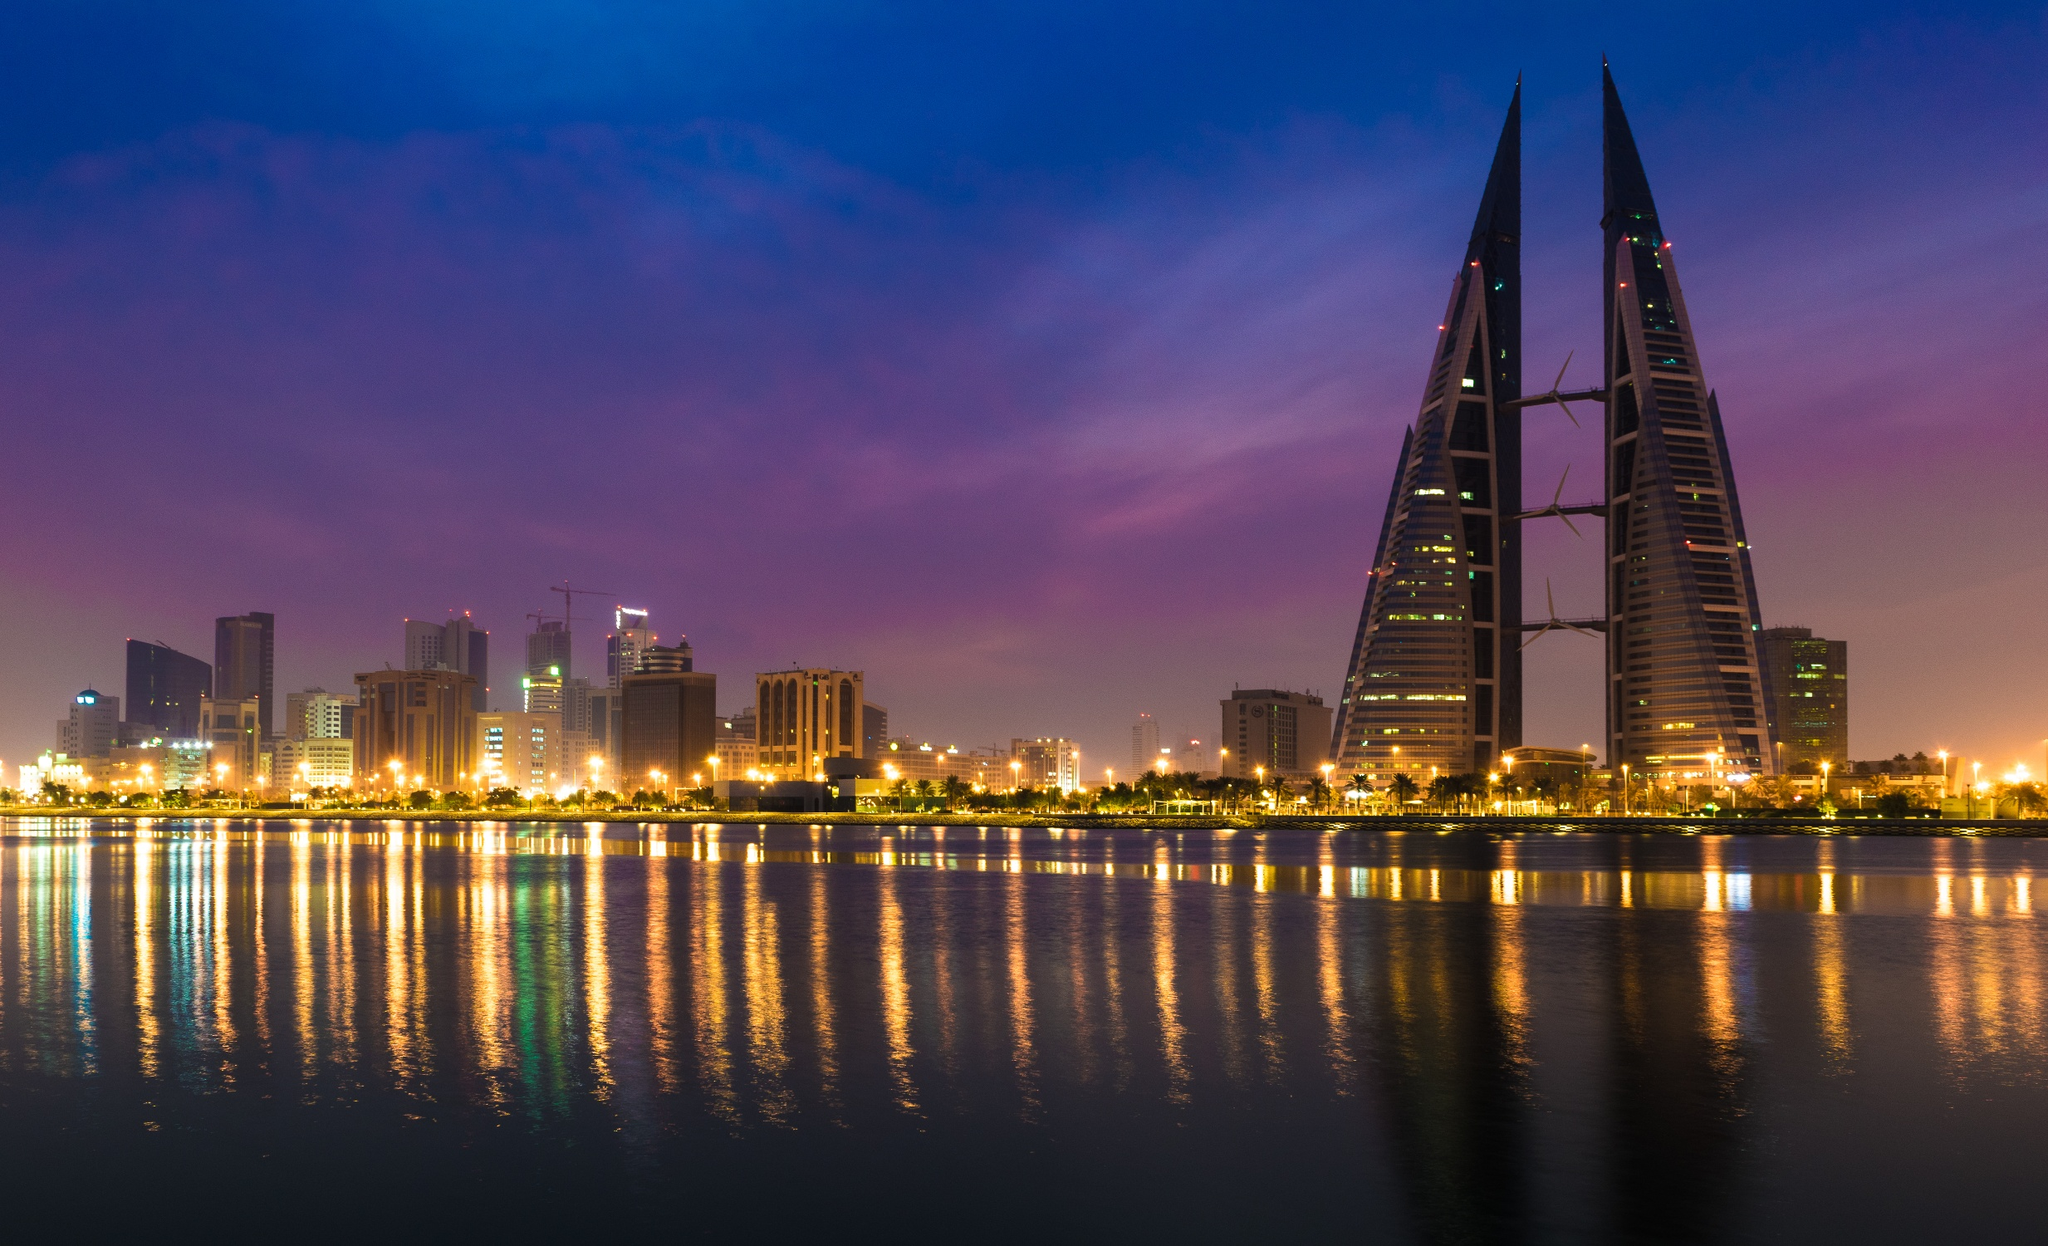What's happening in the scene? The image showcases a stunning night view of the Bahrain World Trade Center, a notable architectural landmark in Manama, Bahrain. The twin towers stand prominently on the right, their sleek, triangular forms beautifully illuminated by white lights, which reflect on the calm waters below. The left side of the image features the city’s skyline, dotted with lit buildings that add depth and contrast to the scene. The sky is painted in serene shades of purple and pink, adding a tranquil and almost surreal ambiance to the overall composition. The photograph seems to be taken from across the water, ensuring a comprehensive and captivating view of the towers and their elegant surroundings. The identifier "sa_13905" likely refers to the specific viewpoint or photograph itself. 